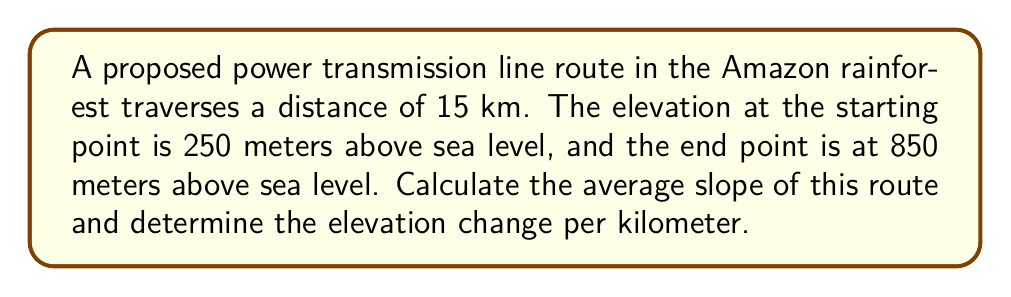Solve this math problem. To solve this problem, we'll follow these steps:

1) Calculate the total elevation change:
   $\Delta \text{elevation} = \text{End elevation} - \text{Start elevation}$
   $\Delta \text{elevation} = 850 \text{ m} - 250 \text{ m} = 600 \text{ m}$

2) Calculate the average slope:
   The slope is typically expressed as a percentage and is calculated as:
   
   $$\text{Slope} = \frac{\text{Rise}}{\text{Run}} \times 100\%$$
   
   Where "Rise" is the elevation change and "Run" is the horizontal distance.
   
   $$\text{Slope} = \frac{600 \text{ m}}{15000 \text{ m}} \times 100\% = 0.04 \times 100\% = 4\%$$

3) Calculate the elevation change per kilometer:
   To find this, we divide the total elevation change by the total distance in kilometers:
   
   $$\text{Elevation change per km} = \frac{600 \text{ m}}{15 \text{ km}} = 40 \text{ m/km}$$

Thus, the route has an average slope of 4% and gains 40 meters in elevation for every kilometer of horizontal distance.
Answer: 4% slope; 40 m/km elevation change 